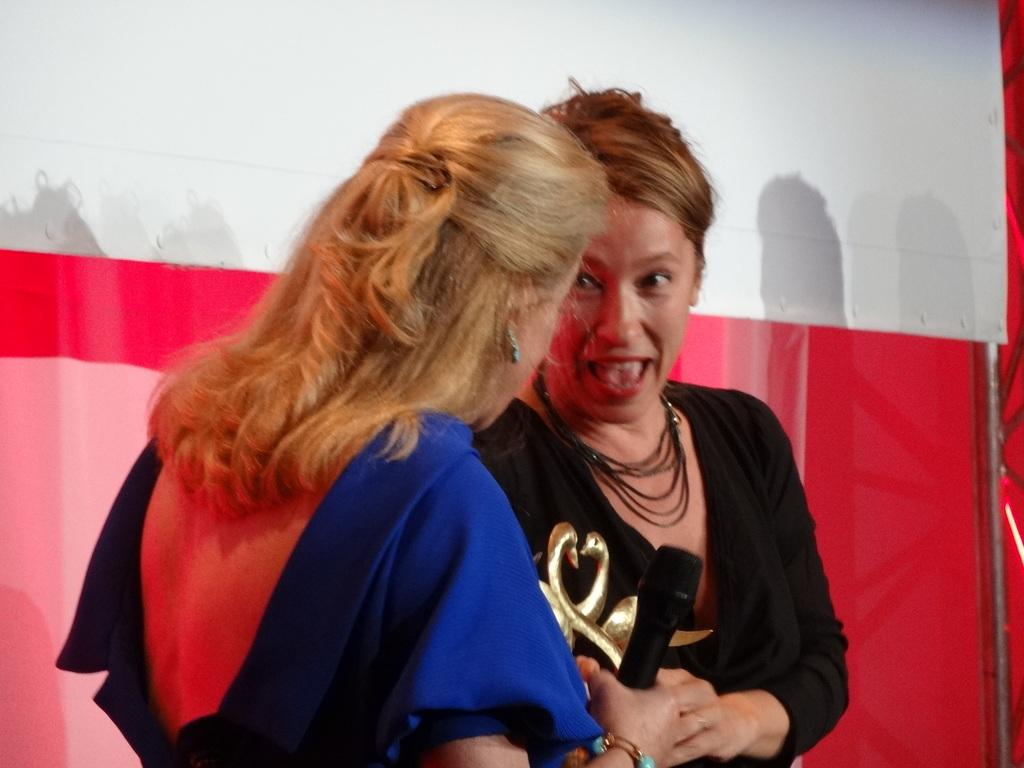How many people are in the image? There are two women standing in the image. What is one of the women holding? One of the women is holding a microphone. What can be seen behind the women? There appears to be a banner behind the women. What other object is visible in the image? There is a pole visible in the image. Can you see any squirrels climbing on the pole in the image? There are no squirrels visible in the image, and no squirrels are climbing on the pole. 